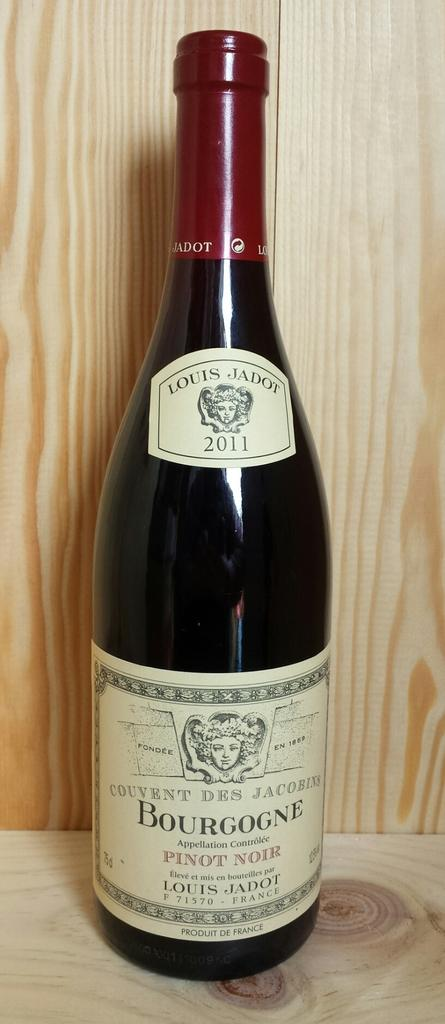<image>
Relay a brief, clear account of the picture shown. AN AMBER BOTTLE OF BOURGONE WINE BY LOUIS JADOT 